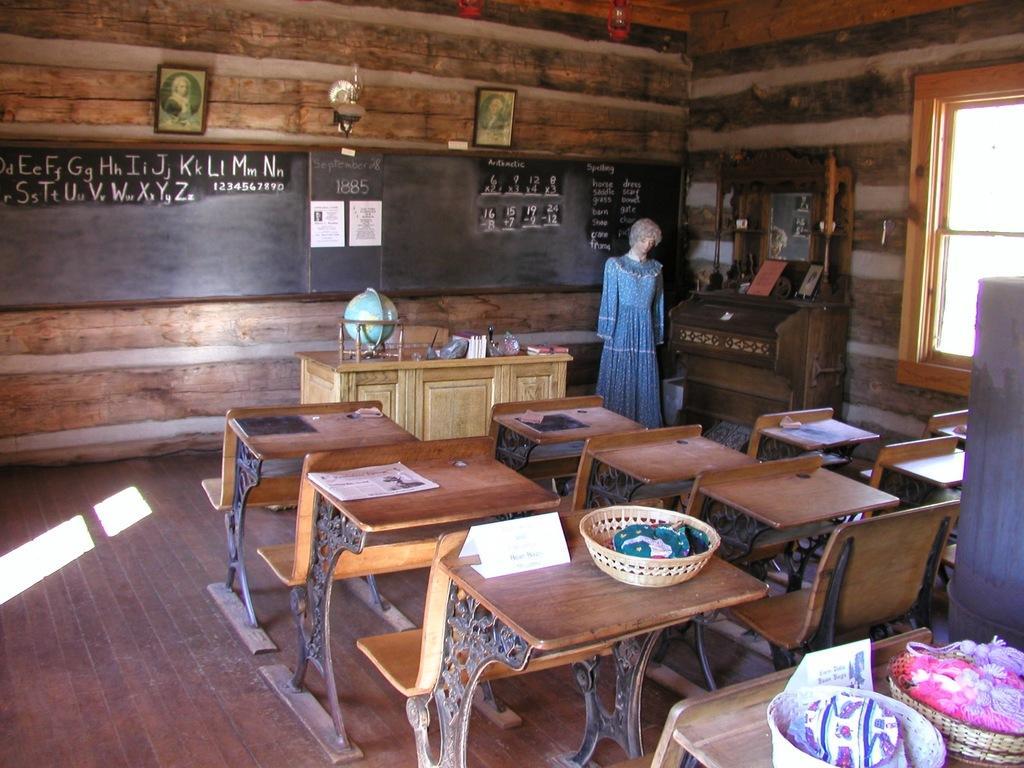Could you give a brief overview of what you see in this image? In this image there are tables and benches, on table there are baskets in that baskets there are objects, in front of the table there is a desk on that desk there is a globe, pen and papers near the desk there is a doll, in the background there is a black board on that black board there is text written and there is wall to that wall there is a photo frame. 